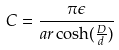Convert formula to latex. <formula><loc_0><loc_0><loc_500><loc_500>C = \frac { \pi \epsilon } { a r \cosh ( \frac { D } { d } ) }</formula> 